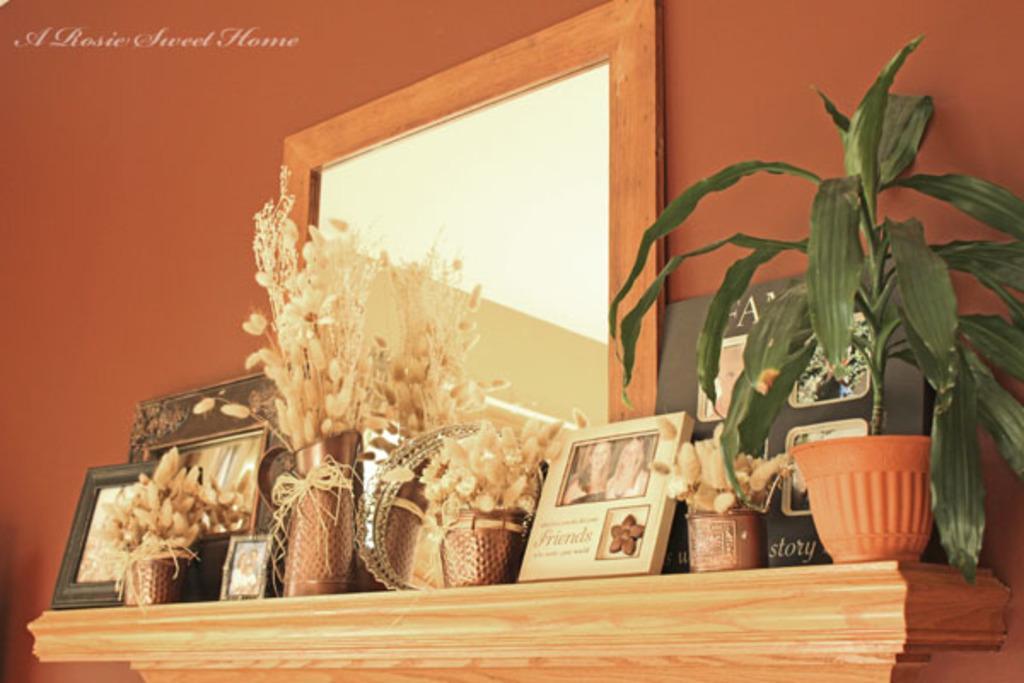How would you summarize this image in a sentence or two? In the center of this picture we can see a wooden shelf on the top of which house plant, flower vases, picture frames and some other items are placed and we can see the wall mounted mirror. In the top left corner we can see the watermark on the image. 